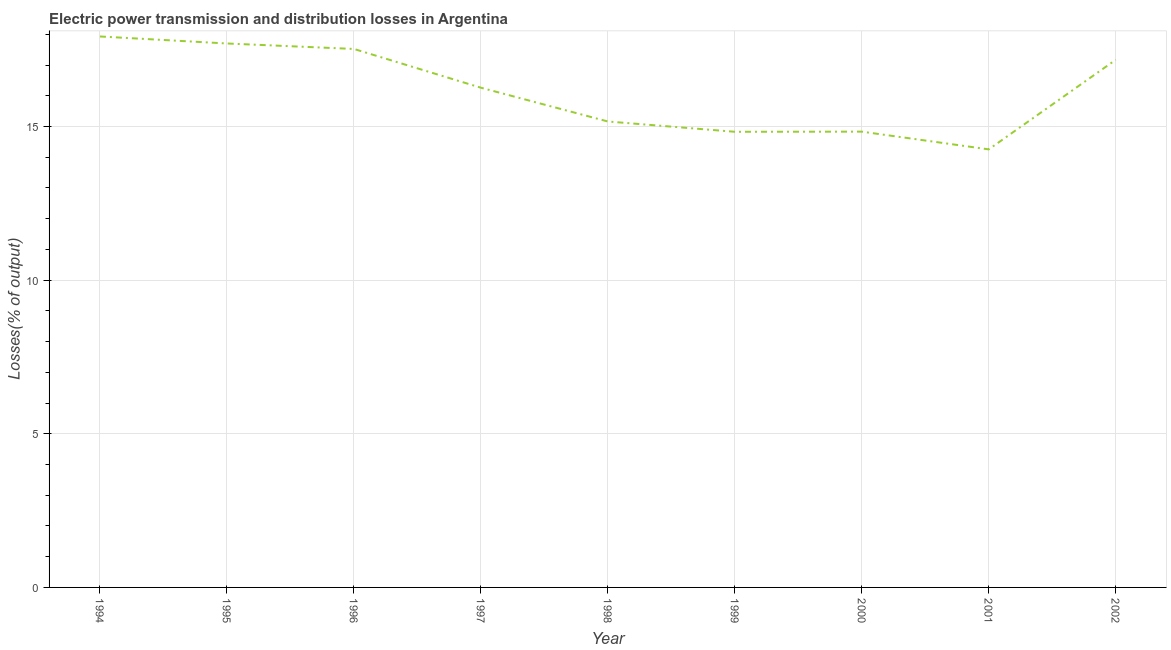What is the electric power transmission and distribution losses in 1997?
Your answer should be very brief. 16.26. Across all years, what is the maximum electric power transmission and distribution losses?
Your answer should be very brief. 17.93. Across all years, what is the minimum electric power transmission and distribution losses?
Keep it short and to the point. 14.26. In which year was the electric power transmission and distribution losses minimum?
Your answer should be very brief. 2001. What is the sum of the electric power transmission and distribution losses?
Provide a succinct answer. 145.67. What is the difference between the electric power transmission and distribution losses in 1997 and 2000?
Offer a very short reply. 1.43. What is the average electric power transmission and distribution losses per year?
Your response must be concise. 16.19. What is the median electric power transmission and distribution losses?
Give a very brief answer. 16.26. Do a majority of the years between 1995 and 2000 (inclusive) have electric power transmission and distribution losses greater than 7 %?
Your response must be concise. Yes. What is the ratio of the electric power transmission and distribution losses in 1994 to that in 1999?
Ensure brevity in your answer.  1.21. Is the electric power transmission and distribution losses in 1996 less than that in 1997?
Offer a very short reply. No. Is the difference between the electric power transmission and distribution losses in 1994 and 2001 greater than the difference between any two years?
Your answer should be compact. Yes. What is the difference between the highest and the second highest electric power transmission and distribution losses?
Your answer should be compact. 0.23. What is the difference between the highest and the lowest electric power transmission and distribution losses?
Provide a succinct answer. 3.67. In how many years, is the electric power transmission and distribution losses greater than the average electric power transmission and distribution losses taken over all years?
Keep it short and to the point. 5. Does the electric power transmission and distribution losses monotonically increase over the years?
Offer a very short reply. No. How many lines are there?
Offer a terse response. 1. What is the title of the graph?
Your response must be concise. Electric power transmission and distribution losses in Argentina. What is the label or title of the Y-axis?
Keep it short and to the point. Losses(% of output). What is the Losses(% of output) in 1994?
Offer a very short reply. 17.93. What is the Losses(% of output) in 1995?
Provide a short and direct response. 17.7. What is the Losses(% of output) in 1996?
Your answer should be compact. 17.52. What is the Losses(% of output) of 1997?
Offer a very short reply. 16.26. What is the Losses(% of output) of 1998?
Make the answer very short. 15.16. What is the Losses(% of output) of 1999?
Provide a succinct answer. 14.83. What is the Losses(% of output) of 2000?
Your answer should be very brief. 14.83. What is the Losses(% of output) of 2001?
Provide a short and direct response. 14.26. What is the Losses(% of output) of 2002?
Your response must be concise. 17.17. What is the difference between the Losses(% of output) in 1994 and 1995?
Make the answer very short. 0.23. What is the difference between the Losses(% of output) in 1994 and 1996?
Offer a terse response. 0.41. What is the difference between the Losses(% of output) in 1994 and 1997?
Keep it short and to the point. 1.67. What is the difference between the Losses(% of output) in 1994 and 1998?
Provide a short and direct response. 2.77. What is the difference between the Losses(% of output) in 1994 and 1999?
Provide a succinct answer. 3.1. What is the difference between the Losses(% of output) in 1994 and 2000?
Provide a succinct answer. 3.1. What is the difference between the Losses(% of output) in 1994 and 2001?
Provide a short and direct response. 3.67. What is the difference between the Losses(% of output) in 1994 and 2002?
Keep it short and to the point. 0.76. What is the difference between the Losses(% of output) in 1995 and 1996?
Offer a terse response. 0.18. What is the difference between the Losses(% of output) in 1995 and 1997?
Provide a succinct answer. 1.44. What is the difference between the Losses(% of output) in 1995 and 1998?
Your answer should be compact. 2.54. What is the difference between the Losses(% of output) in 1995 and 1999?
Keep it short and to the point. 2.87. What is the difference between the Losses(% of output) in 1995 and 2000?
Your answer should be compact. 2.87. What is the difference between the Losses(% of output) in 1995 and 2001?
Provide a short and direct response. 3.45. What is the difference between the Losses(% of output) in 1995 and 2002?
Your response must be concise. 0.53. What is the difference between the Losses(% of output) in 1996 and 1997?
Your answer should be very brief. 1.26. What is the difference between the Losses(% of output) in 1996 and 1998?
Ensure brevity in your answer.  2.36. What is the difference between the Losses(% of output) in 1996 and 1999?
Provide a succinct answer. 2.7. What is the difference between the Losses(% of output) in 1996 and 2000?
Provide a succinct answer. 2.69. What is the difference between the Losses(% of output) in 1996 and 2001?
Provide a short and direct response. 3.27. What is the difference between the Losses(% of output) in 1996 and 2002?
Your answer should be very brief. 0.35. What is the difference between the Losses(% of output) in 1997 and 1998?
Make the answer very short. 1.1. What is the difference between the Losses(% of output) in 1997 and 1999?
Provide a short and direct response. 1.43. What is the difference between the Losses(% of output) in 1997 and 2000?
Give a very brief answer. 1.43. What is the difference between the Losses(% of output) in 1997 and 2001?
Offer a terse response. 2.01. What is the difference between the Losses(% of output) in 1997 and 2002?
Ensure brevity in your answer.  -0.91. What is the difference between the Losses(% of output) in 1998 and 1999?
Provide a succinct answer. 0.34. What is the difference between the Losses(% of output) in 1998 and 2000?
Give a very brief answer. 0.33. What is the difference between the Losses(% of output) in 1998 and 2001?
Your answer should be very brief. 0.91. What is the difference between the Losses(% of output) in 1998 and 2002?
Offer a terse response. -2.01. What is the difference between the Losses(% of output) in 1999 and 2000?
Your answer should be compact. -0. What is the difference between the Losses(% of output) in 1999 and 2001?
Provide a succinct answer. 0.57. What is the difference between the Losses(% of output) in 1999 and 2002?
Make the answer very short. -2.34. What is the difference between the Losses(% of output) in 2000 and 2001?
Offer a very short reply. 0.58. What is the difference between the Losses(% of output) in 2000 and 2002?
Make the answer very short. -2.34. What is the difference between the Losses(% of output) in 2001 and 2002?
Your answer should be very brief. -2.91. What is the ratio of the Losses(% of output) in 1994 to that in 1997?
Ensure brevity in your answer.  1.1. What is the ratio of the Losses(% of output) in 1994 to that in 1998?
Provide a short and direct response. 1.18. What is the ratio of the Losses(% of output) in 1994 to that in 1999?
Give a very brief answer. 1.21. What is the ratio of the Losses(% of output) in 1994 to that in 2000?
Your answer should be very brief. 1.21. What is the ratio of the Losses(% of output) in 1994 to that in 2001?
Your answer should be very brief. 1.26. What is the ratio of the Losses(% of output) in 1994 to that in 2002?
Your response must be concise. 1.04. What is the ratio of the Losses(% of output) in 1995 to that in 1996?
Provide a short and direct response. 1.01. What is the ratio of the Losses(% of output) in 1995 to that in 1997?
Your answer should be compact. 1.09. What is the ratio of the Losses(% of output) in 1995 to that in 1998?
Give a very brief answer. 1.17. What is the ratio of the Losses(% of output) in 1995 to that in 1999?
Offer a very short reply. 1.19. What is the ratio of the Losses(% of output) in 1995 to that in 2000?
Give a very brief answer. 1.19. What is the ratio of the Losses(% of output) in 1995 to that in 2001?
Your answer should be compact. 1.24. What is the ratio of the Losses(% of output) in 1995 to that in 2002?
Keep it short and to the point. 1.03. What is the ratio of the Losses(% of output) in 1996 to that in 1997?
Give a very brief answer. 1.08. What is the ratio of the Losses(% of output) in 1996 to that in 1998?
Provide a succinct answer. 1.16. What is the ratio of the Losses(% of output) in 1996 to that in 1999?
Offer a very short reply. 1.18. What is the ratio of the Losses(% of output) in 1996 to that in 2000?
Your answer should be compact. 1.18. What is the ratio of the Losses(% of output) in 1996 to that in 2001?
Your response must be concise. 1.23. What is the ratio of the Losses(% of output) in 1996 to that in 2002?
Your answer should be compact. 1.02. What is the ratio of the Losses(% of output) in 1997 to that in 1998?
Make the answer very short. 1.07. What is the ratio of the Losses(% of output) in 1997 to that in 1999?
Offer a terse response. 1.1. What is the ratio of the Losses(% of output) in 1997 to that in 2000?
Provide a short and direct response. 1.1. What is the ratio of the Losses(% of output) in 1997 to that in 2001?
Your answer should be compact. 1.14. What is the ratio of the Losses(% of output) in 1997 to that in 2002?
Keep it short and to the point. 0.95. What is the ratio of the Losses(% of output) in 1998 to that in 2001?
Provide a succinct answer. 1.06. What is the ratio of the Losses(% of output) in 1998 to that in 2002?
Offer a terse response. 0.88. What is the ratio of the Losses(% of output) in 1999 to that in 2002?
Keep it short and to the point. 0.86. What is the ratio of the Losses(% of output) in 2000 to that in 2001?
Offer a very short reply. 1.04. What is the ratio of the Losses(% of output) in 2000 to that in 2002?
Offer a terse response. 0.86. What is the ratio of the Losses(% of output) in 2001 to that in 2002?
Provide a short and direct response. 0.83. 